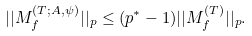Convert formula to latex. <formula><loc_0><loc_0><loc_500><loc_500>| | M _ { f } ^ { ( T ; A , \psi ) } | | _ { p } \leq ( p ^ { * } - 1 ) | | M _ { f } ^ { ( T ) } | | _ { p } .</formula> 